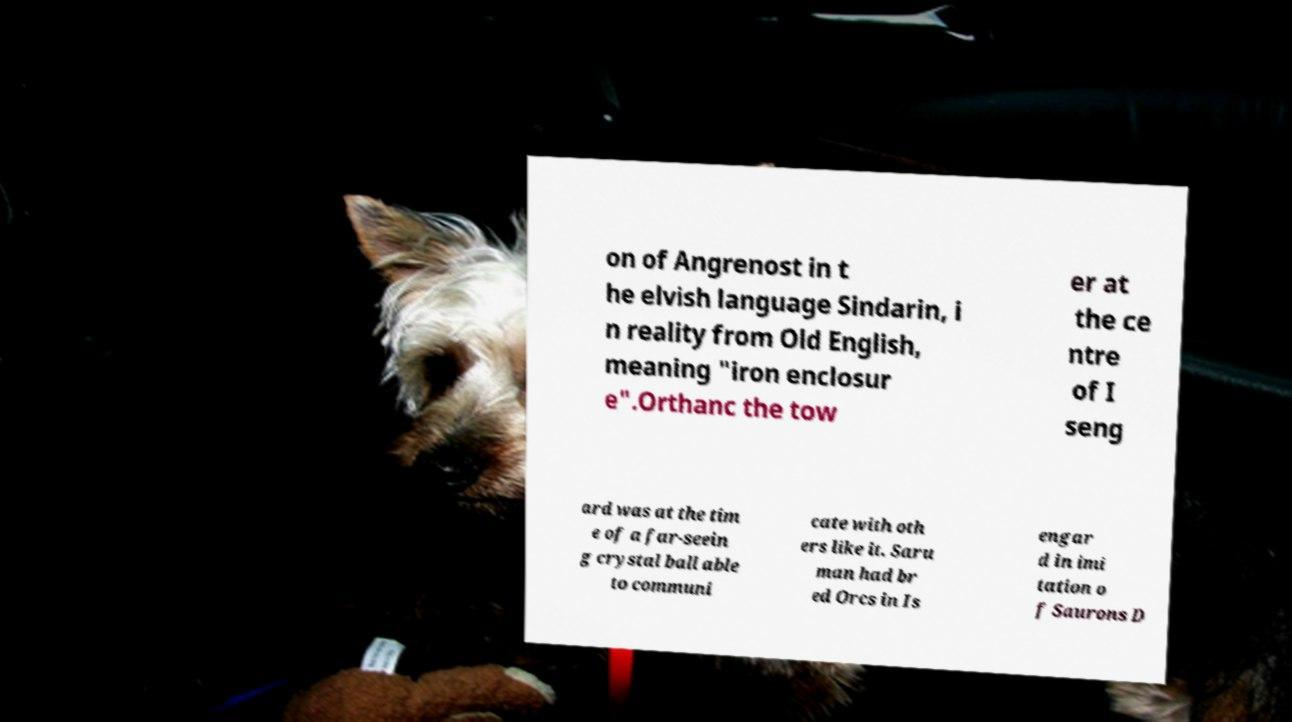Could you extract and type out the text from this image? on of Angrenost in t he elvish language Sindarin, i n reality from Old English, meaning "iron enclosur e".Orthanc the tow er at the ce ntre of I seng ard was at the tim e of a far-seein g crystal ball able to communi cate with oth ers like it. Saru man had br ed Orcs in Is engar d in imi tation o f Saurons D 